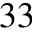<formula> <loc_0><loc_0><loc_500><loc_500>3 3</formula> 